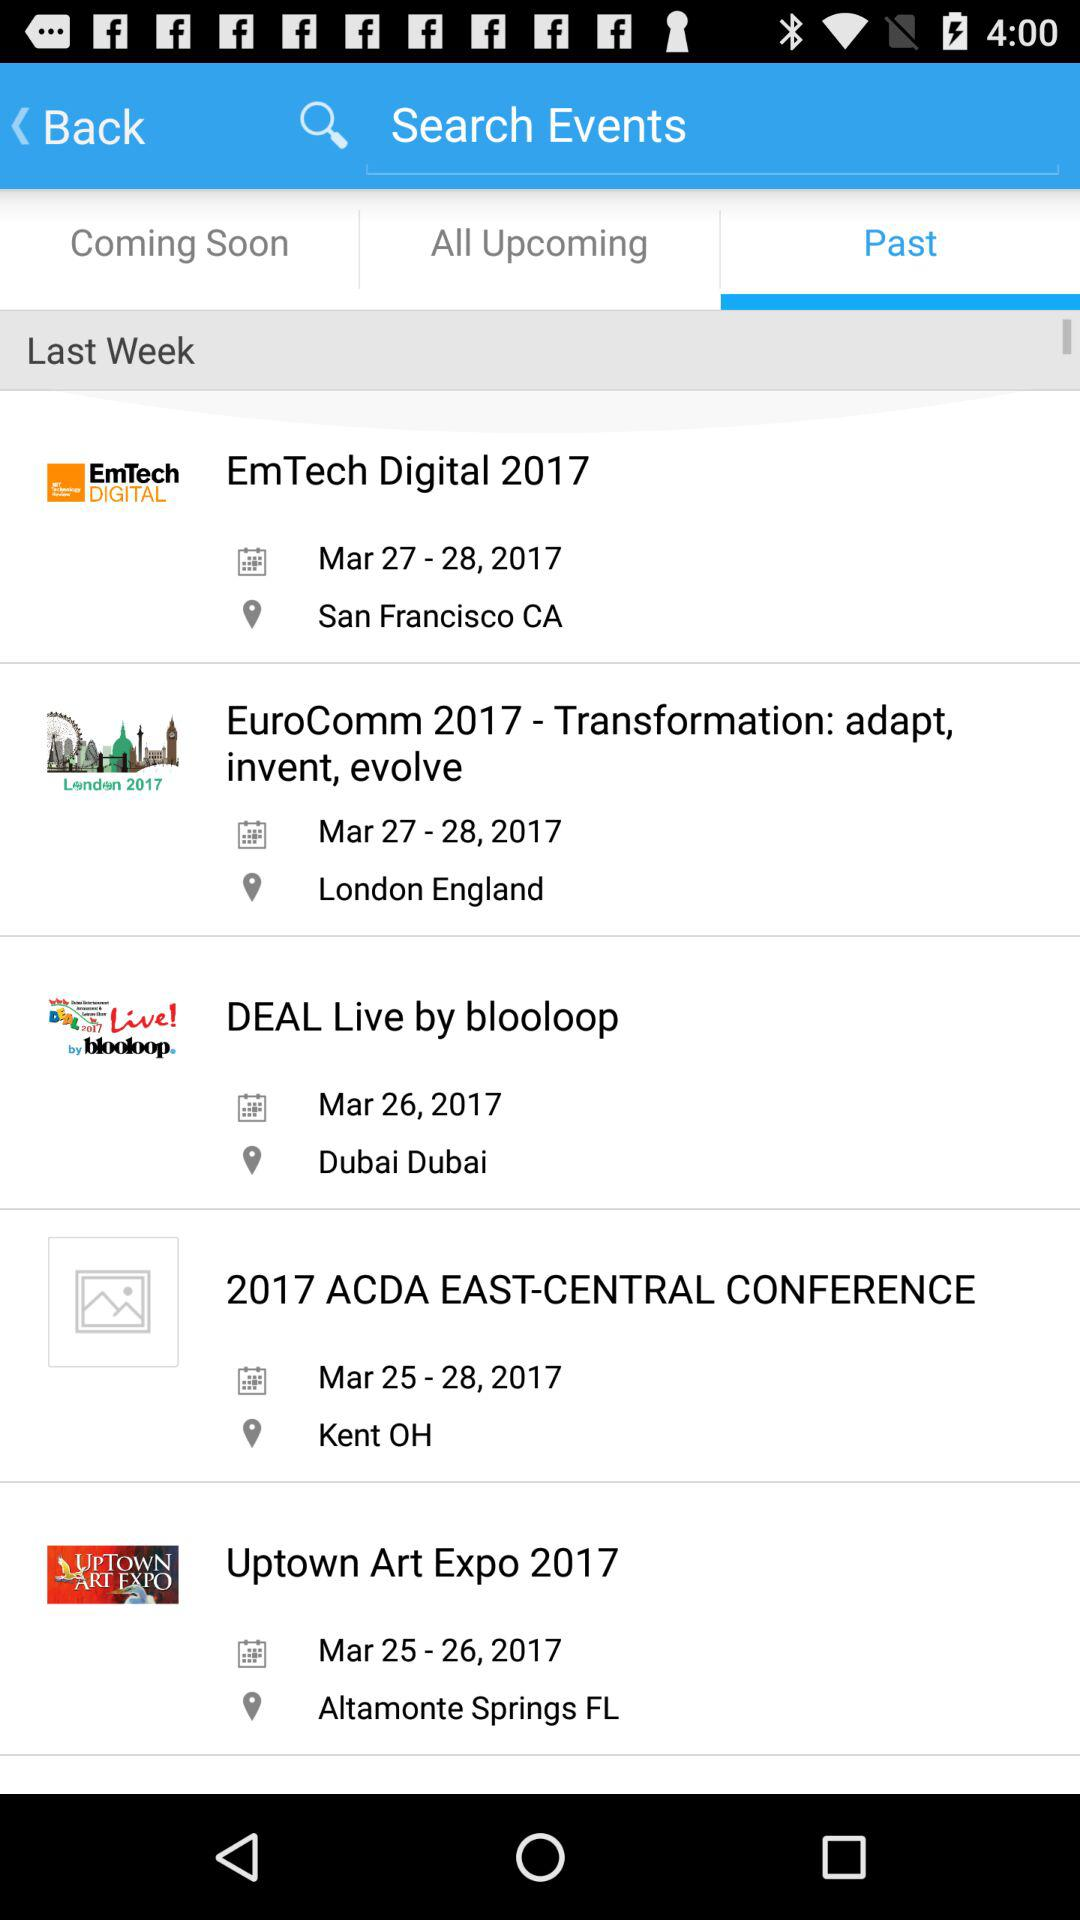What is the location of "EmTech Digital 2017"? The location is San Francisco, CA. 